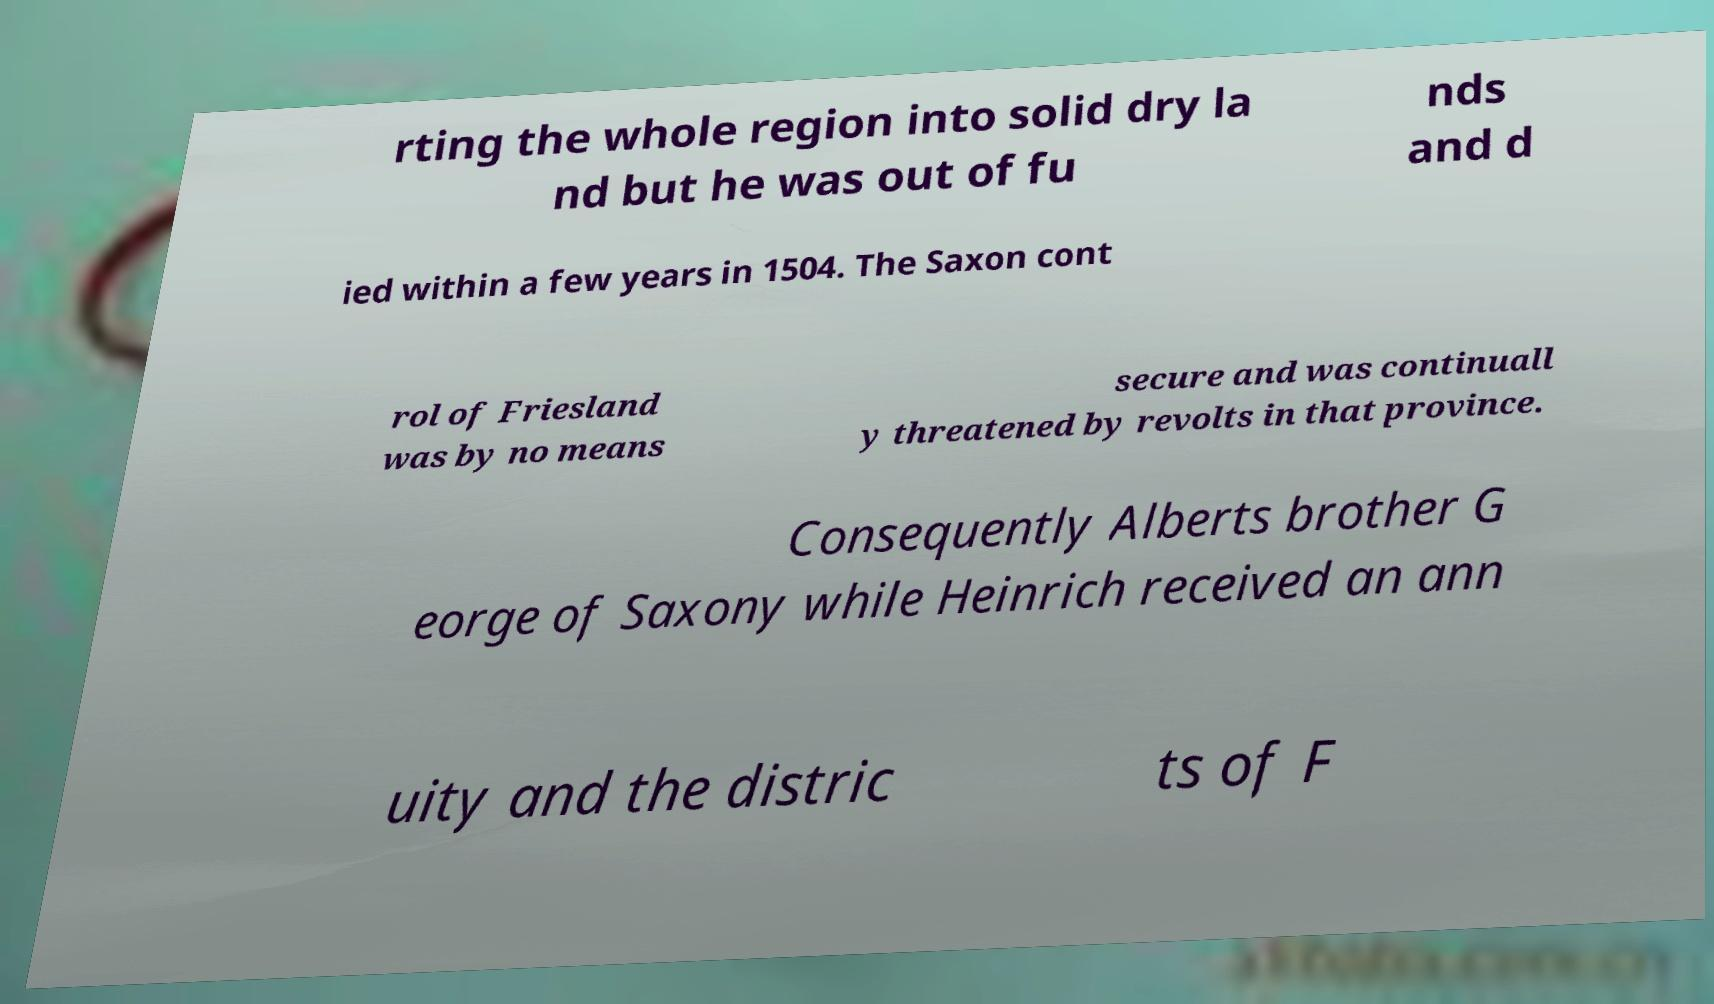Can you read and provide the text displayed in the image?This photo seems to have some interesting text. Can you extract and type it out for me? rting the whole region into solid dry la nd but he was out of fu nds and d ied within a few years in 1504. The Saxon cont rol of Friesland was by no means secure and was continuall y threatened by revolts in that province. Consequently Alberts brother G eorge of Saxony while Heinrich received an ann uity and the distric ts of F 